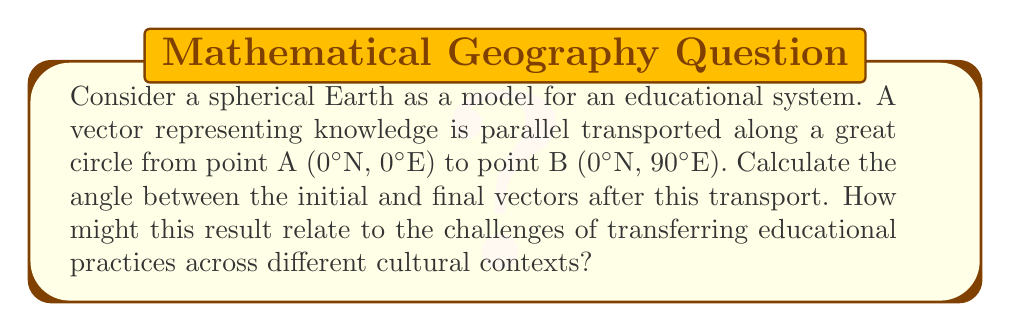Can you solve this math problem? Let's approach this step-by-step:

1) In differential geometry, parallel transport on a sphere results in a rotation of the vector due to the curvature of the surface. This rotation is related to the area enclosed by the path of transport.

2) For a great circle path on a sphere, the angle of rotation $\theta$ is given by:

   $$\theta = \Omega$$

   where $\Omega$ is the solid angle subtended by the path at the center of the sphere.

3) For a quarter of a great circle (90° or $\frac{\pi}{2}$ radians), the solid angle is:

   $$\Omega = \frac{\pi}{2}$$

4) Therefore, the angle between the initial and final vectors is:

   $$\theta = \frac{\pi}{2} = 90°$$

5) This result can be interpreted in the context of education:
   - The rotation of the vector represents how knowledge or educational practices may need to be "rotated" or adapted when transferred to a different context.
   - The significant 90° rotation suggests that direct, unmodified transfer of educational practices across widely different contexts (represented by the quarter turn around the Earth) may not be effective.
   - Just as the vector ends up perpendicular to its starting orientation, educational practices may need to be fundamentally reoriented to fit new cultural contexts.

6) This geometric analogy highlights the importance of considering local context, culture, and existing educational frameworks when attempting to transfer or implement educational practices across different systems or regions.
Answer: 90°; represents need for significant adaptation of educational practices across different contexts. 